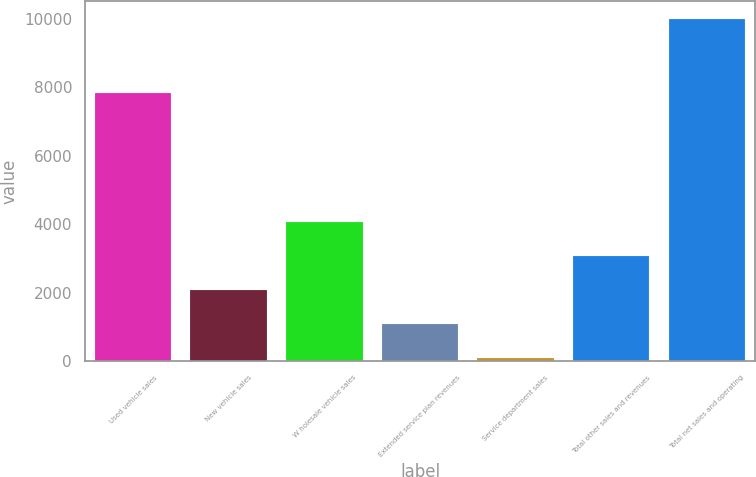<chart> <loc_0><loc_0><loc_500><loc_500><bar_chart><fcel>Used vehicle sales<fcel>New vehicle sales<fcel>W holesale vehicle sales<fcel>Extended service plan revenues<fcel>Service department sales<fcel>Total other sales and revenues<fcel>Total net sales and operating<nl><fcel>7826.9<fcel>2079.6<fcel>4060.6<fcel>1089.1<fcel>98.6<fcel>3070.1<fcel>10003.6<nl></chart> 